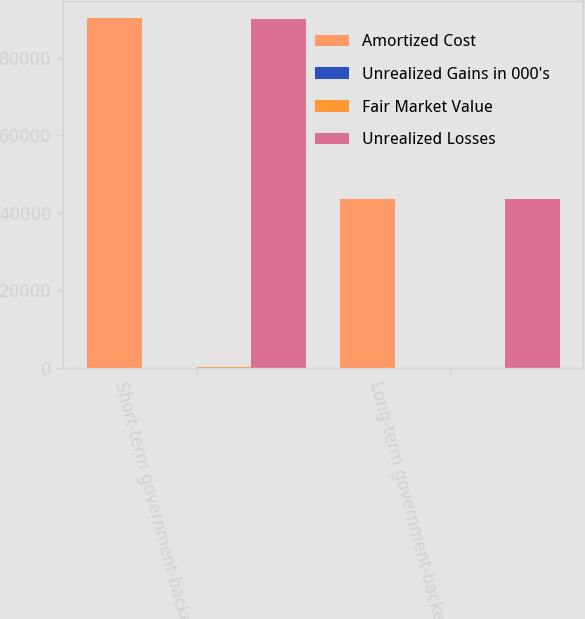Convert chart. <chart><loc_0><loc_0><loc_500><loc_500><stacked_bar_chart><ecel><fcel>Short-term government-backed<fcel>Long-term government-backed<nl><fcel>Amortized Cost<fcel>90199<fcel>43484<nl><fcel>Unrealized Gains in 000's<fcel>1<fcel>5<nl><fcel>Fair Market Value<fcel>87<fcel>18<nl><fcel>Unrealized Losses<fcel>90113<fcel>43471<nl></chart> 